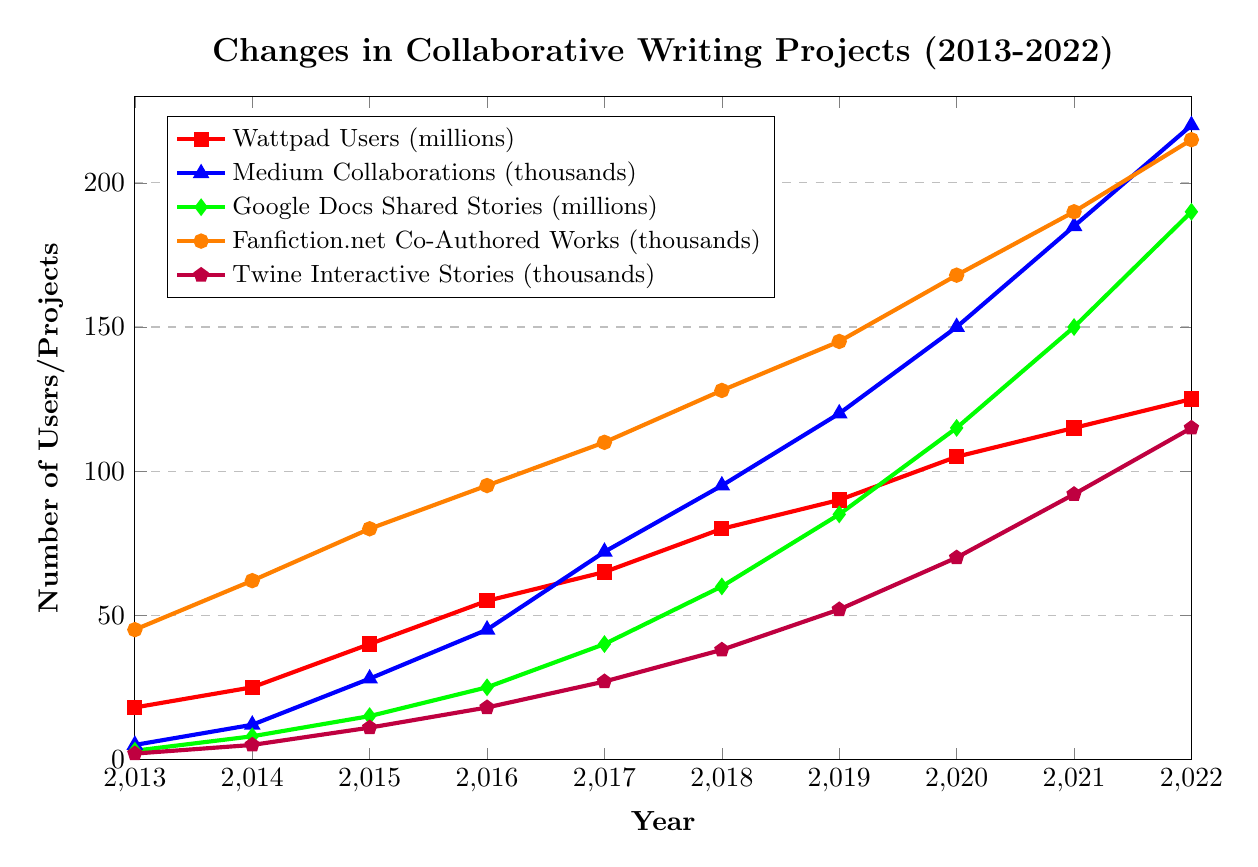What's the overall trend of Wattpad Users from 2013 to 2022? Observing the line chart (red line), the number of Wattpad Users increases each year, suggesting a steady growth trend.
Answer: Steady growth Which platform saw the highest increase in projects/users from 2013 to 2022? To determine this, we calculate the difference between the 2022 and 2013 values for each platform: Wattpad Users (125-18=107 million), Medium Collaborations (220-5=215 thousand), Google Docs Shared Stories (190-3=187 million), Fanfiction.net Co-Authored Works (215-45=170 thousand), Twine Interactive Stories (115-2=113 thousand). Medium Collaborations showed the highest increase.
Answer: Medium Collaborations By how many projects did Google Docs Shared Stories grow from 2013 to 2022? The number of Google Docs Shared Stories in 2022 is 190 million, and in 2013 it was 3 million. The growth is calculated by 190 - 3 = 187 million.
Answer: 187 million Which platform had the highest number of projects/users in 2019? Comparing the 2019 values: Wattpad Users (90 million), Medium Collaborations (120 thousand), Google Docs Shared Stories (85 million), Fanfiction.net Co-Authored Works (145 thousand), Twine Interactive Stories (52 thousand). Google Docs Shared Stories had the highest number at 85 million.
Answer: Google Docs Shared Stories What is the average number of Fanfiction.net Co-Authored Works from 2013 to 2022? Summing up the values for Fanfiction.net Co-Authored Works (45+62+80+95+110+128+145+168+190+215 = 1238 thousand) and then dividing by the number of years (10), we get 1238/10 = 123.8 thousand.
Answer: 123.8 thousand In which year did Medium Collaborations first exceed 100 thousand projects? Observing the blue line, Medium Collaborations first exceeded 100 thousand between 2017 and 2018. By checking the exact values, in 2018 it was at 95 thousand, and in 2019 it reached 120 thousand. The first year exceeding 100 thousand is 2019.
Answer: 2019 How does the growth of Twine Interactive Stories compare to Google Docs Shared Stories between 2014 and 2016? For Twine Interactive Stories: 2014 (5 thousand) to 2016 (18 thousand) is a growth of 13 thousand. For Google Docs Shared Stories: 2014 (8 million) to 2016 (25 million) is a growth of 17 million. Comparing these two shows Google Docs Shared Stories had a higher growth in their respective units.
Answer: Google Docs Shared Stories had higher growth Did any platform experience a decline in projects/users in any year? By examining the figure, none of the lines show a decrease at any point; they all consistently increase each year.
Answer: No What's the combined total number of projects/users for all platforms in 2022? Summing all 2022 values: Wattpad Users (125), Medium Collaborations (220), Google Docs Shared Stories (190), Fanfiction.net Co-Authored Works (215), Twine Interactive Stories (115), we get 125 + 220 + 190 + 215 + 115 = 865 million/thousands.
Answer: 865 million/thousands 